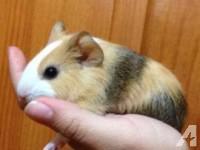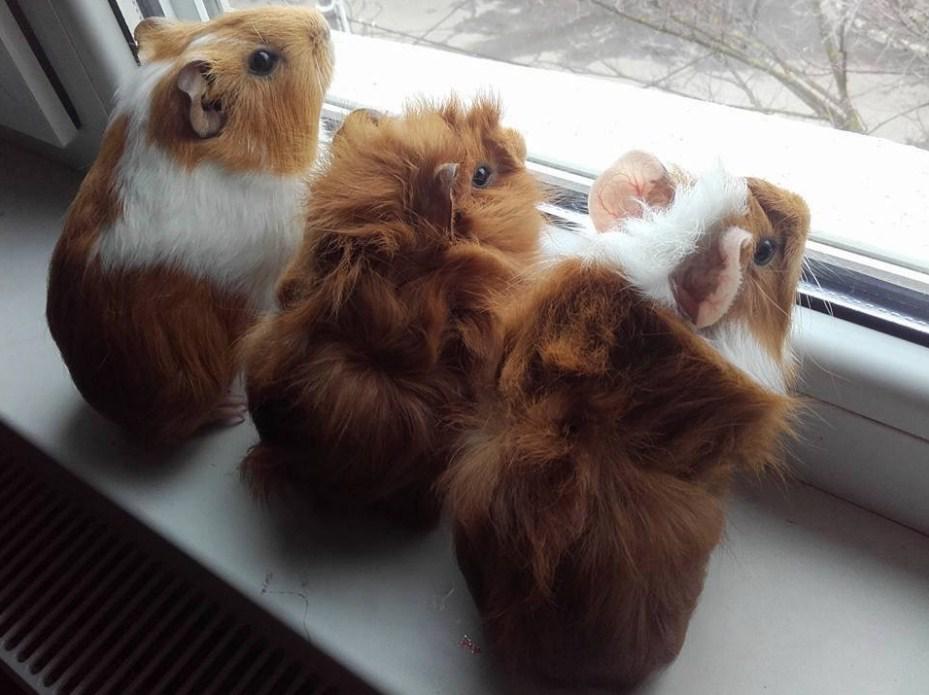The first image is the image on the left, the second image is the image on the right. Analyze the images presented: Is the assertion "One image shows a single multicolor pet rodent held in a human hand." valid? Answer yes or no. Yes. The first image is the image on the left, the second image is the image on the right. Given the left and right images, does the statement "The right image contains exactly two guinea pigs." hold true? Answer yes or no. No. 